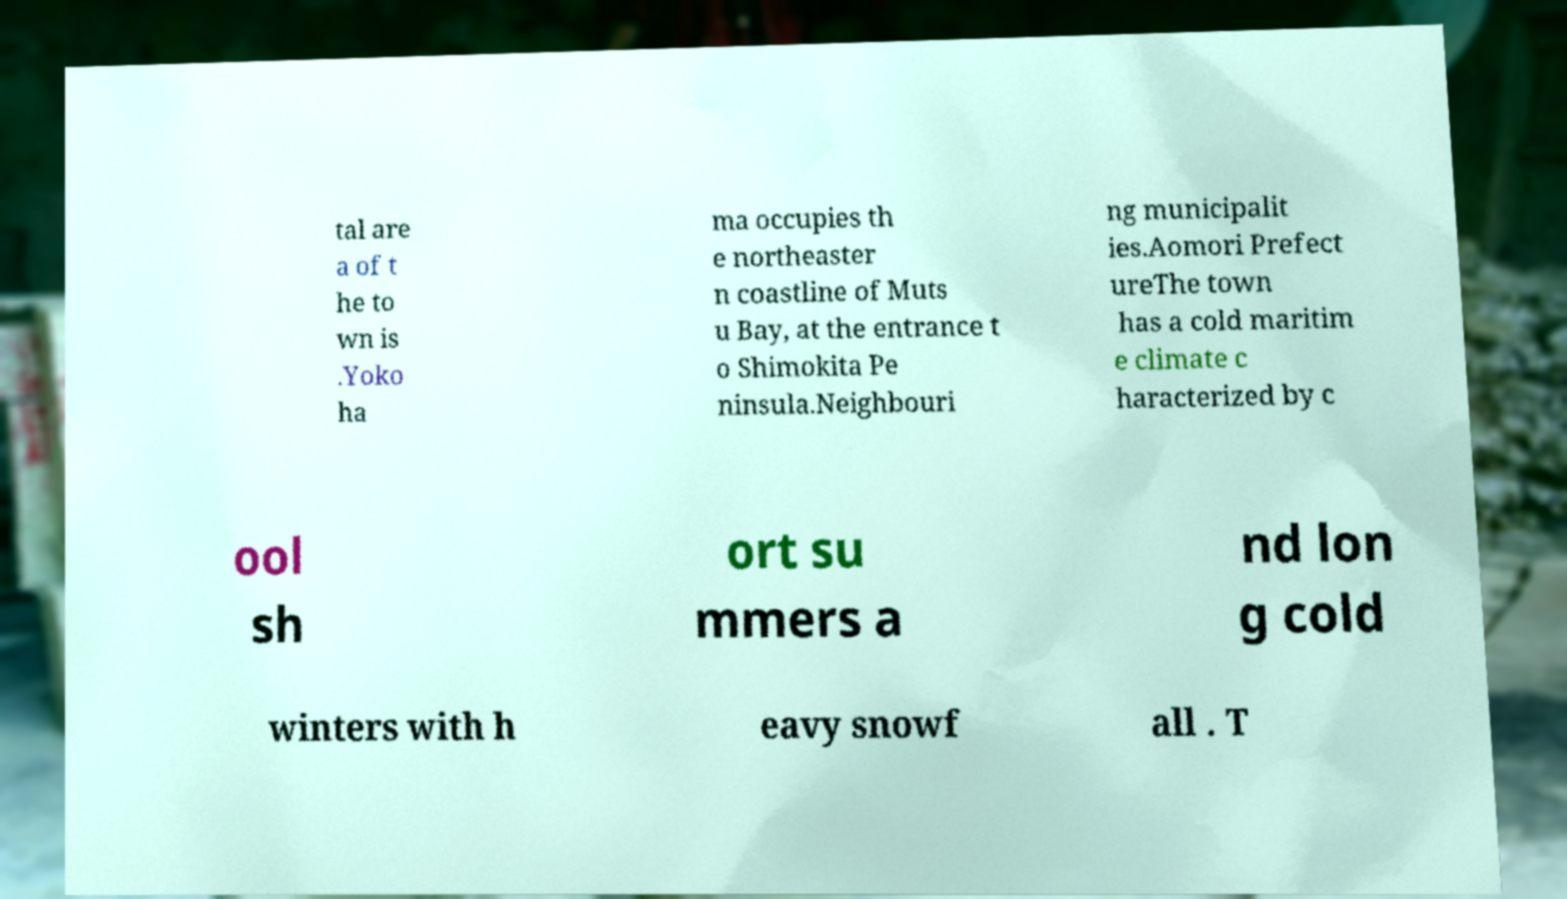There's text embedded in this image that I need extracted. Can you transcribe it verbatim? tal are a of t he to wn is .Yoko ha ma occupies th e northeaster n coastline of Muts u Bay, at the entrance t o Shimokita Pe ninsula.Neighbouri ng municipalit ies.Aomori Prefect ureThe town has a cold maritim e climate c haracterized by c ool sh ort su mmers a nd lon g cold winters with h eavy snowf all . T 